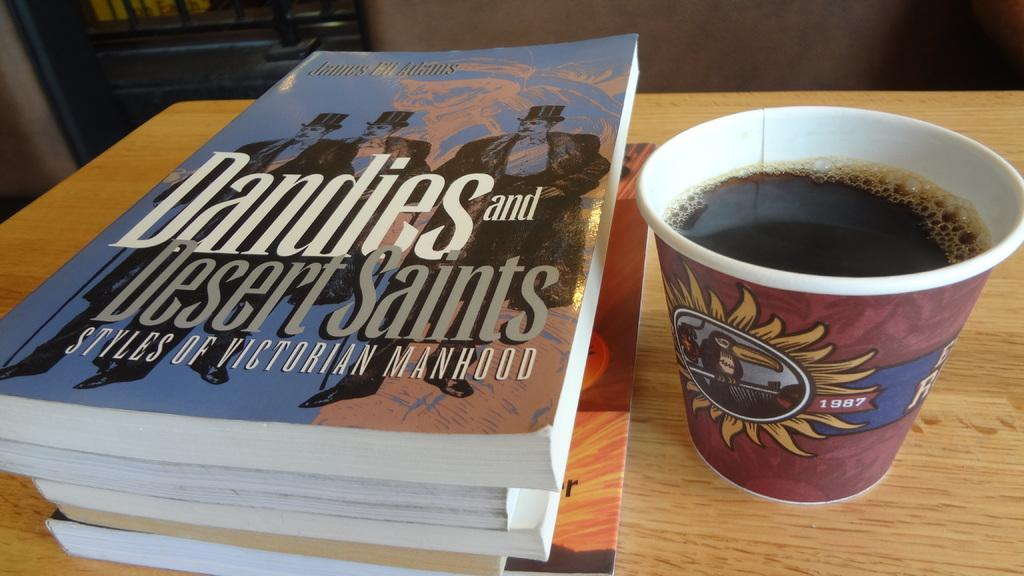<image>
Summarize the visual content of the image. A cup of coffee and a book called Dandies and Desert Saints. 